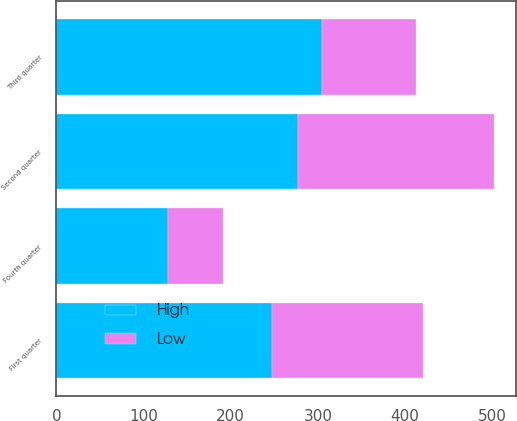Convert chart to OTSL. <chart><loc_0><loc_0><loc_500><loc_500><stacked_bar_chart><ecel><fcel>First quarter<fcel>Second quarter<fcel>Third quarter<fcel>Fourth quarter<nl><fcel>High<fcel>247.55<fcel>277.7<fcel>304.79<fcel>128.5<nl><fcel>Low<fcel>173.5<fcel>224.41<fcel>107.63<fcel>62.37<nl></chart> 